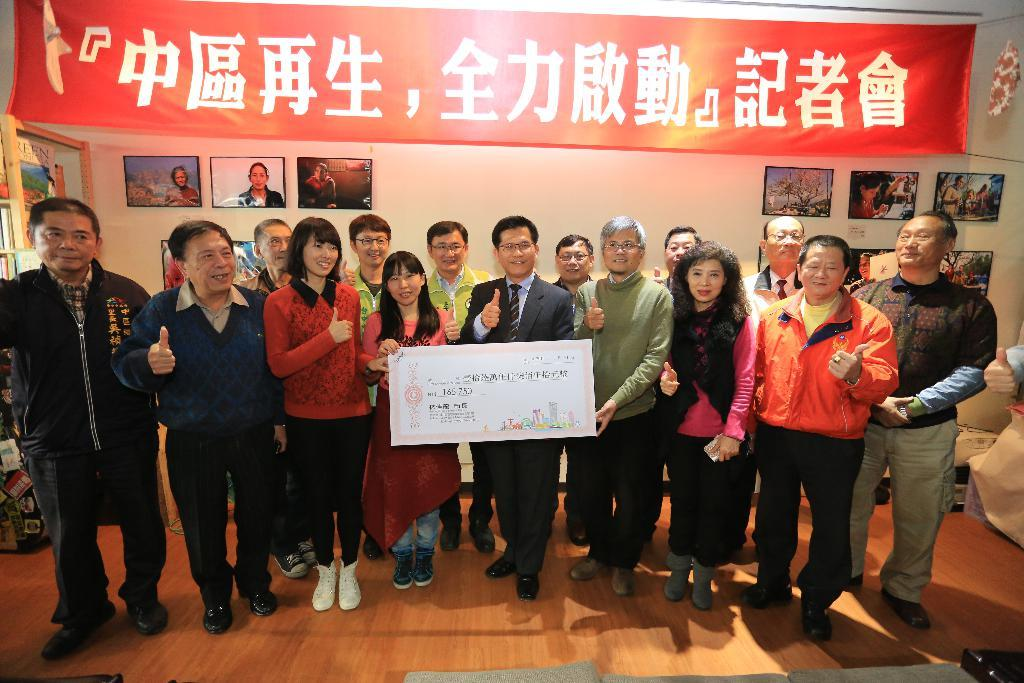What is happening in the image involving a group of people? There is a group of people in the image, and they are standing and smiling. What are the people holding in their hands? The people are holding a cheque in their hands. What can be seen in the background of the image? There is a banner and a wall in the background of the image. What is on the wall in the background? There are photo frames on the wall. What type of boats can be seen sailing in the background of the image? There are no boats visible in the background of the image; it features a banner and a wall with photo frames. What role does salt play in the image? Salt does not play any role in the image, as it is not mentioned or depicted. 